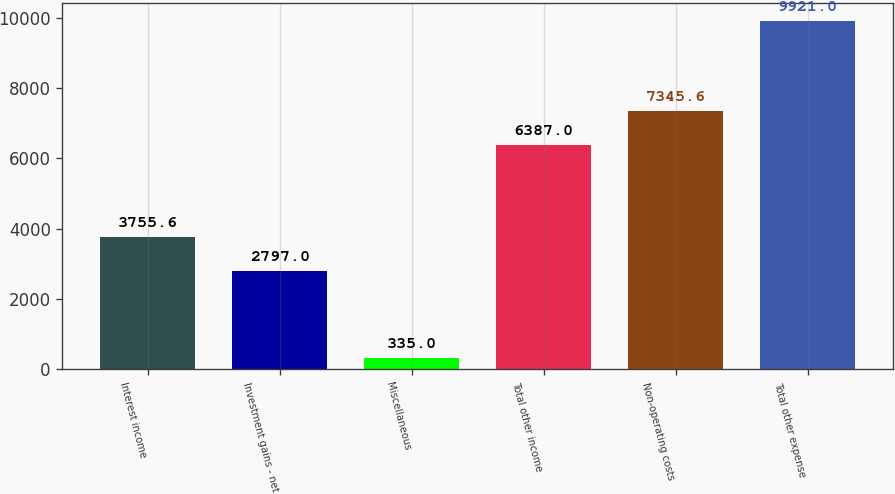Convert chart to OTSL. <chart><loc_0><loc_0><loc_500><loc_500><bar_chart><fcel>Interest income<fcel>Investment gains - net<fcel>Miscellaneous<fcel>Total other income<fcel>Non-operating costs<fcel>Total other expense<nl><fcel>3755.6<fcel>2797<fcel>335<fcel>6387<fcel>7345.6<fcel>9921<nl></chart> 